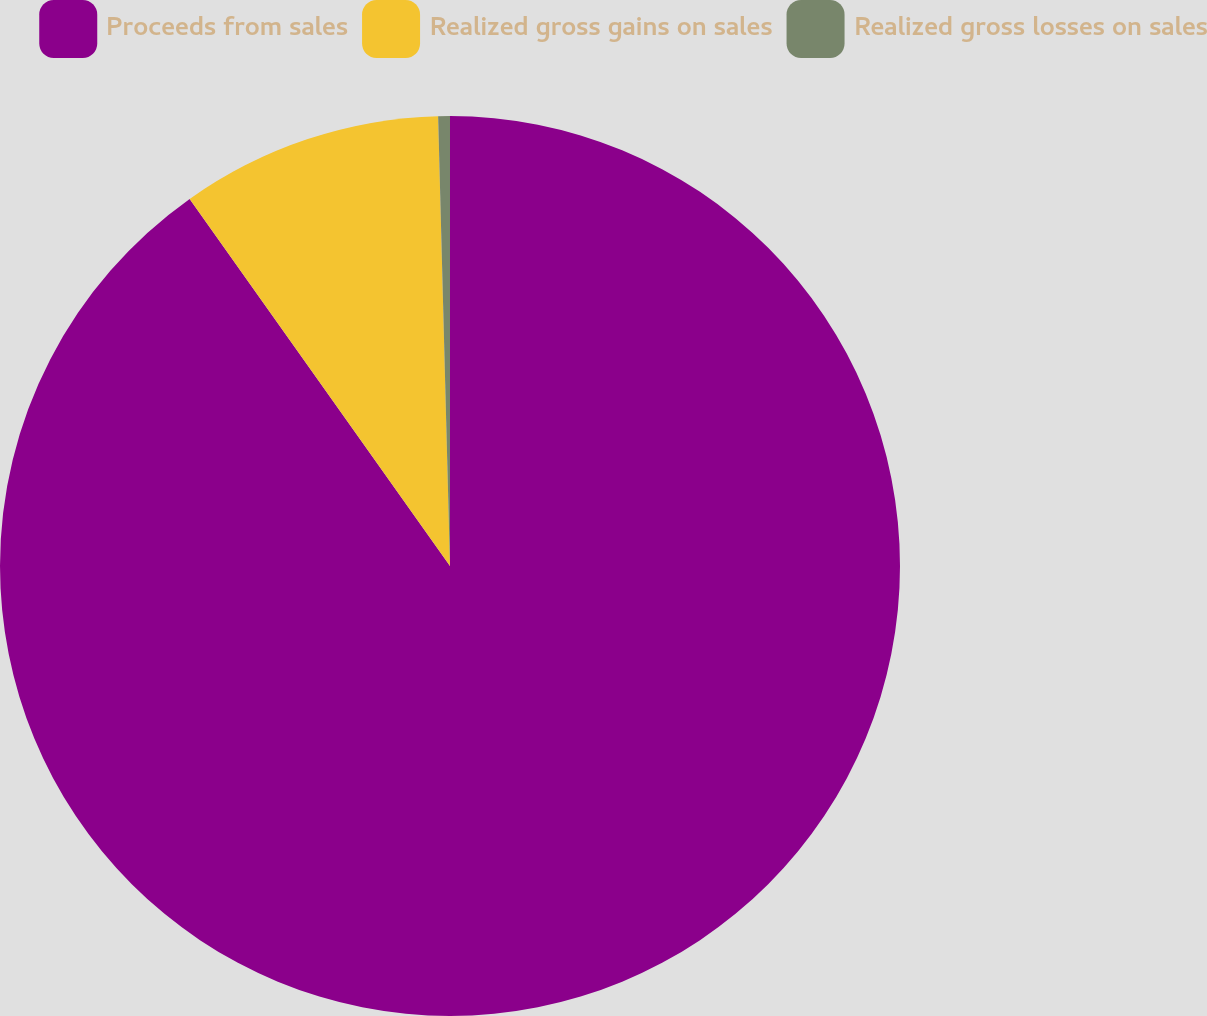Convert chart. <chart><loc_0><loc_0><loc_500><loc_500><pie_chart><fcel>Proceeds from sales<fcel>Realized gross gains on sales<fcel>Realized gross losses on sales<nl><fcel>90.19%<fcel>9.4%<fcel>0.42%<nl></chart> 